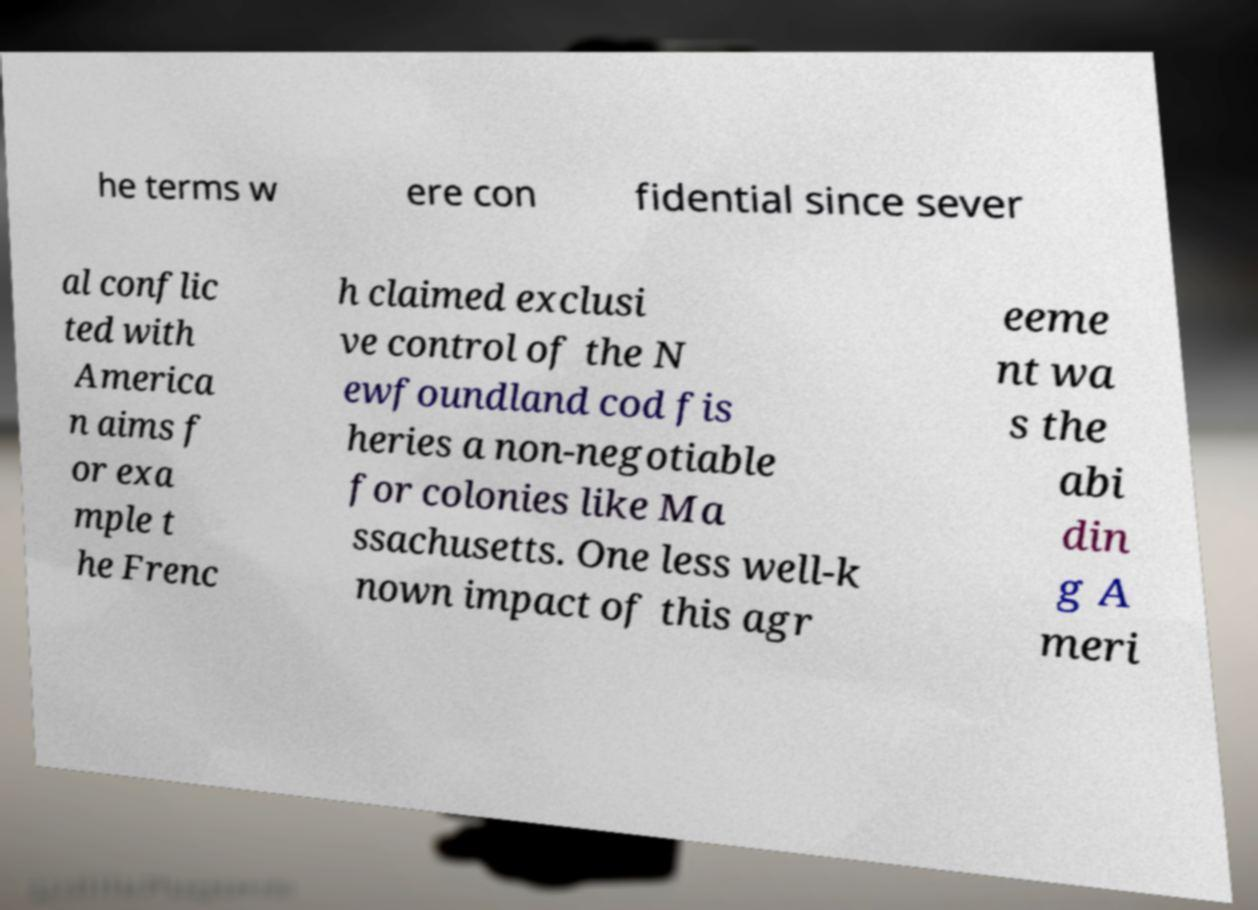For documentation purposes, I need the text within this image transcribed. Could you provide that? he terms w ere con fidential since sever al conflic ted with America n aims f or exa mple t he Frenc h claimed exclusi ve control of the N ewfoundland cod fis heries a non-negotiable for colonies like Ma ssachusetts. One less well-k nown impact of this agr eeme nt wa s the abi din g A meri 